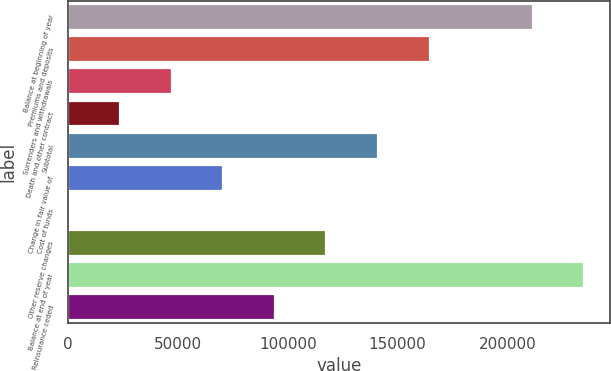Convert chart. <chart><loc_0><loc_0><loc_500><loc_500><bar_chart><fcel>Balance at beginning of year<fcel>Premiums and deposits<fcel>Surrenders and withdrawals<fcel>Death and other contract<fcel>Subtotal<fcel>Change in fair value of<fcel>Cost of funds<fcel>Other reserve changes<fcel>Balance at end of year<fcel>Reinsurance ceded<nl><fcel>211434<fcel>164535<fcel>47285.6<fcel>23835.8<fcel>141085<fcel>70735.4<fcel>386<fcel>117635<fcel>234884<fcel>94185.2<nl></chart> 